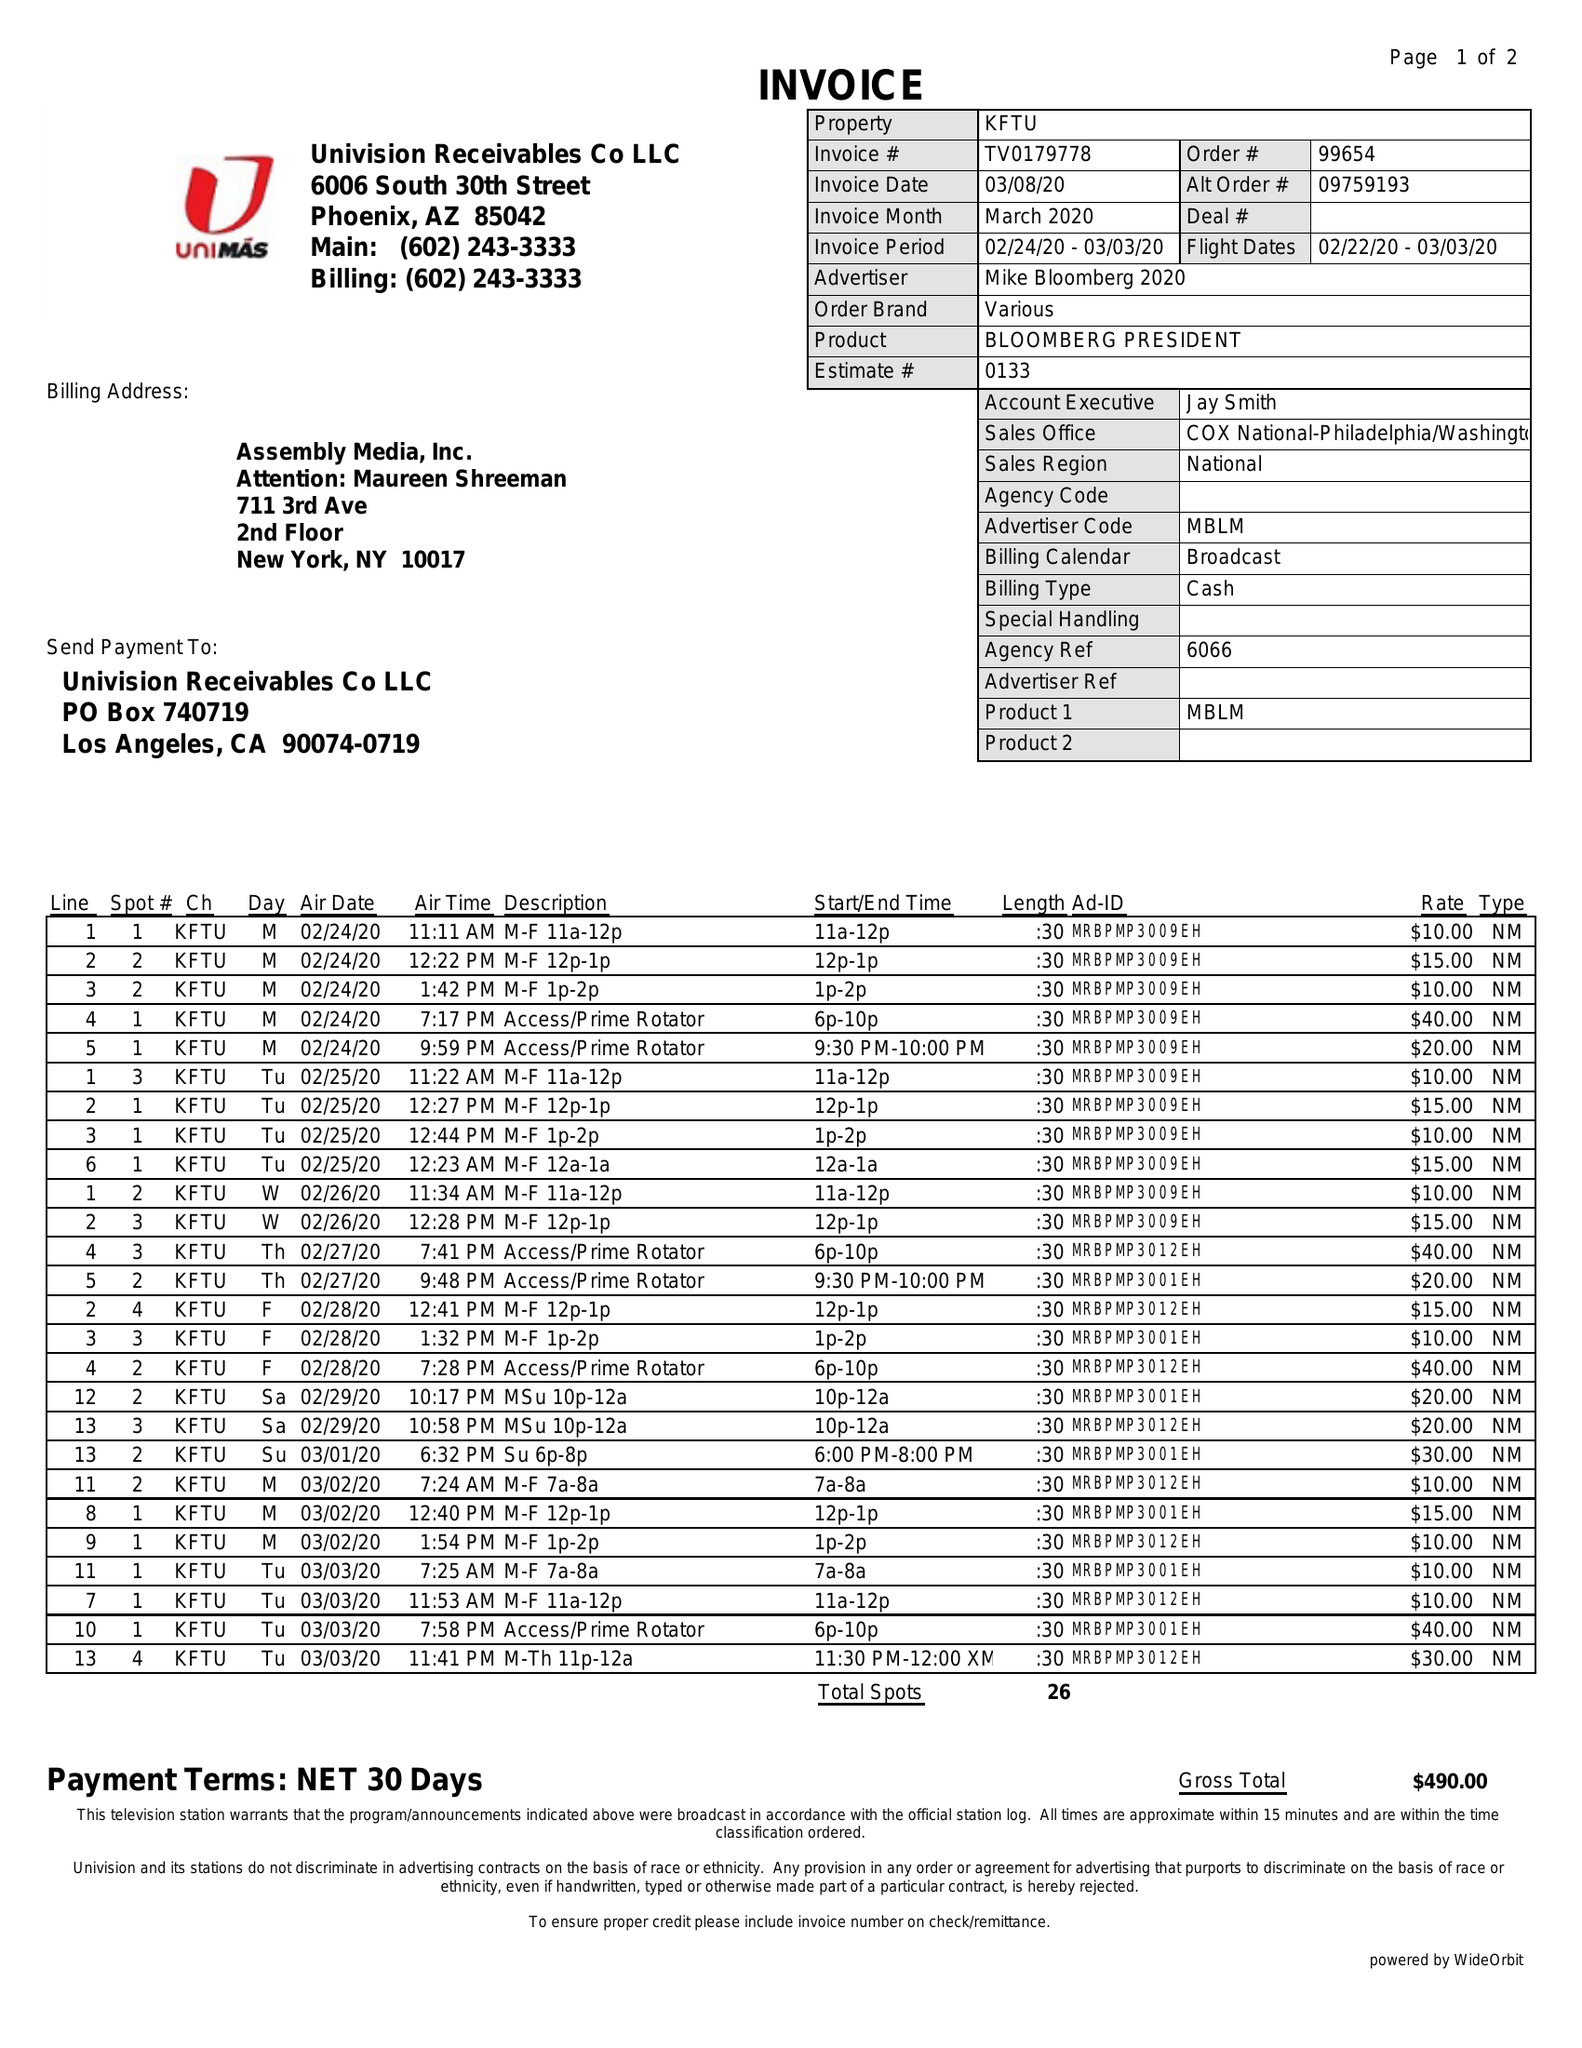What is the value for the gross_amount?
Answer the question using a single word or phrase. 490.00 